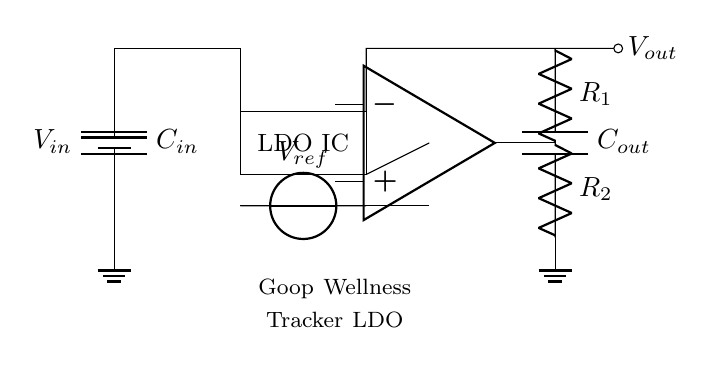What is the input voltage in this circuit? The input voltage is represented by the label V_in at the battery component, indicating it is the source voltage for the circuit.
Answer: V_in What type of components are R_1 and R_2? R_1 and R_2 are resistors used in the feedback network to set the output voltage of the low-dropout regulator.
Answer: Resistors What is the purpose of C_in in this circuit? C_in serves as an input capacitor that stabilizes the input voltage by smoothing out voltage fluctuations before it reaches the LDO IC.
Answer: Input capacitor How many capacitors are there in total? There are two capacitors in the circuit: C_in and C_out, indicated by their respective labels connected within the circuit.
Answer: Two What role does the LDO IC play in this circuit? The LDO IC functions as a linear voltage regulator, ensuring that the output voltage remains stable and within desired specifications despite variations in input voltage or load conditions.
Answer: Voltage regulator What is the reference voltage labeled as? The reference voltage is indicated by the label V_ref, which is crucial for the LDO's operation to maintain a steady output.
Answer: V_ref Why is a low-dropout regulator used in this design? A low-dropout regulator is used to maintain efficient operation with minimal voltage difference between input and output, which is ideal for extending battery life in wearables.
Answer: Battery efficiency 